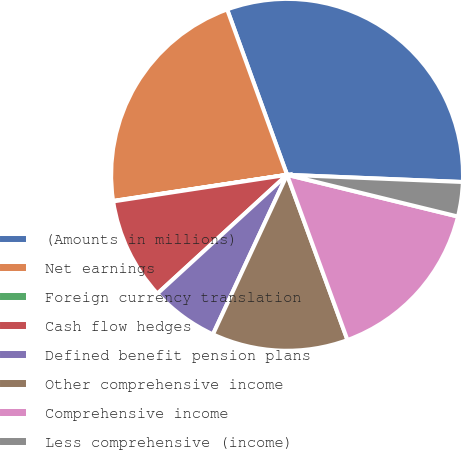<chart> <loc_0><loc_0><loc_500><loc_500><pie_chart><fcel>(Amounts in millions)<fcel>Net earnings<fcel>Foreign currency translation<fcel>Cash flow hedges<fcel>Defined benefit pension plans<fcel>Other comprehensive income<fcel>Comprehensive income<fcel>Less comprehensive (income)<nl><fcel>31.18%<fcel>21.84%<fcel>0.04%<fcel>9.39%<fcel>6.27%<fcel>12.5%<fcel>15.61%<fcel>3.16%<nl></chart> 